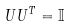Convert formula to latex. <formula><loc_0><loc_0><loc_500><loc_500>U U ^ { T } = \mathbb { I }</formula> 